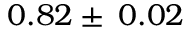Convert formula to latex. <formula><loc_0><loc_0><loc_500><loc_500>0 . 8 2 \pm \, 0 . 0 2</formula> 